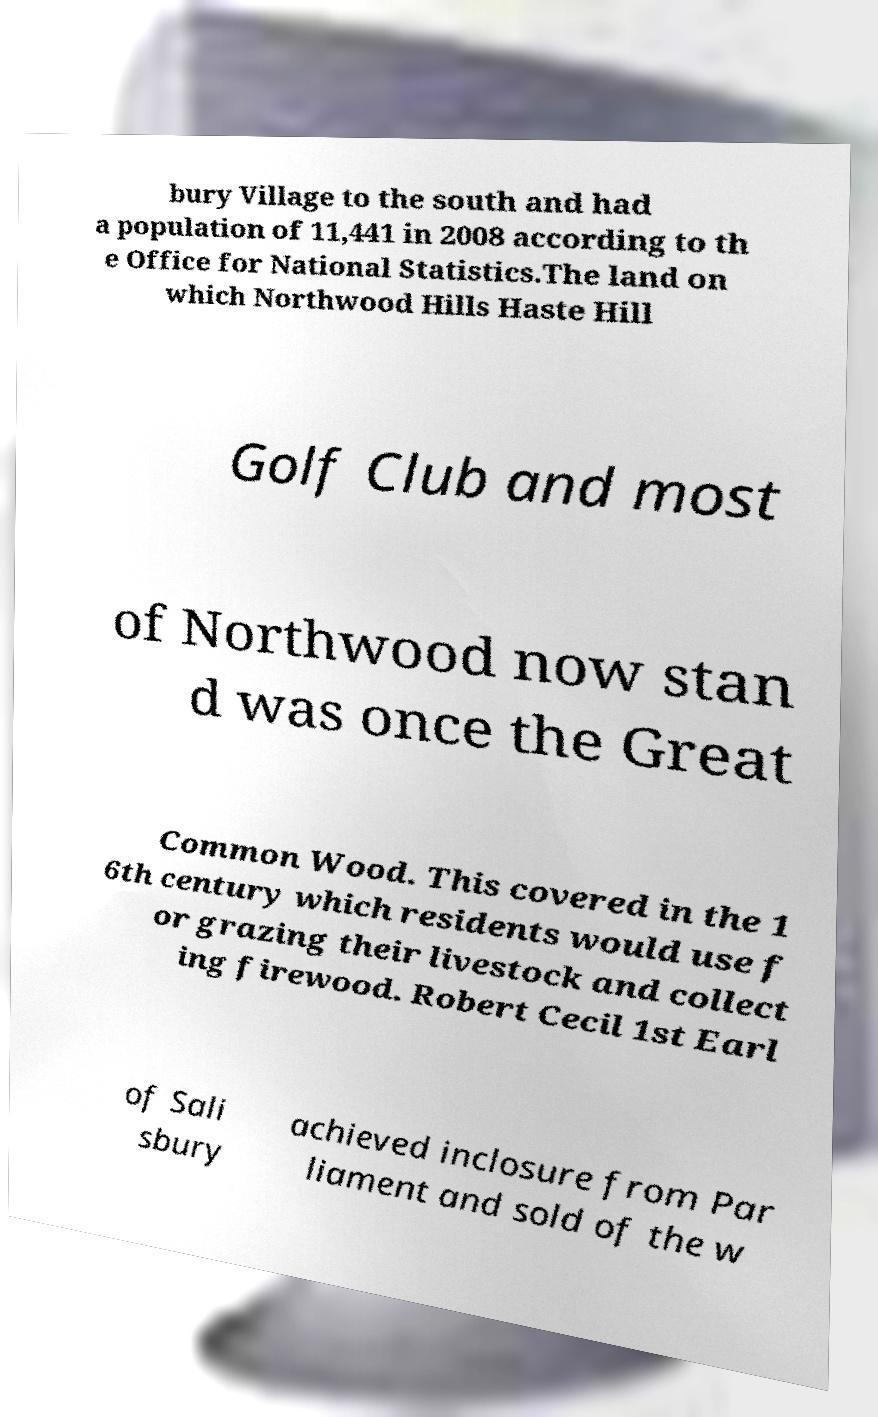There's text embedded in this image that I need extracted. Can you transcribe it verbatim? bury Village to the south and had a population of 11,441 in 2008 according to th e Office for National Statistics.The land on which Northwood Hills Haste Hill Golf Club and most of Northwood now stan d was once the Great Common Wood. This covered in the 1 6th century which residents would use f or grazing their livestock and collect ing firewood. Robert Cecil 1st Earl of Sali sbury achieved inclosure from Par liament and sold of the w 